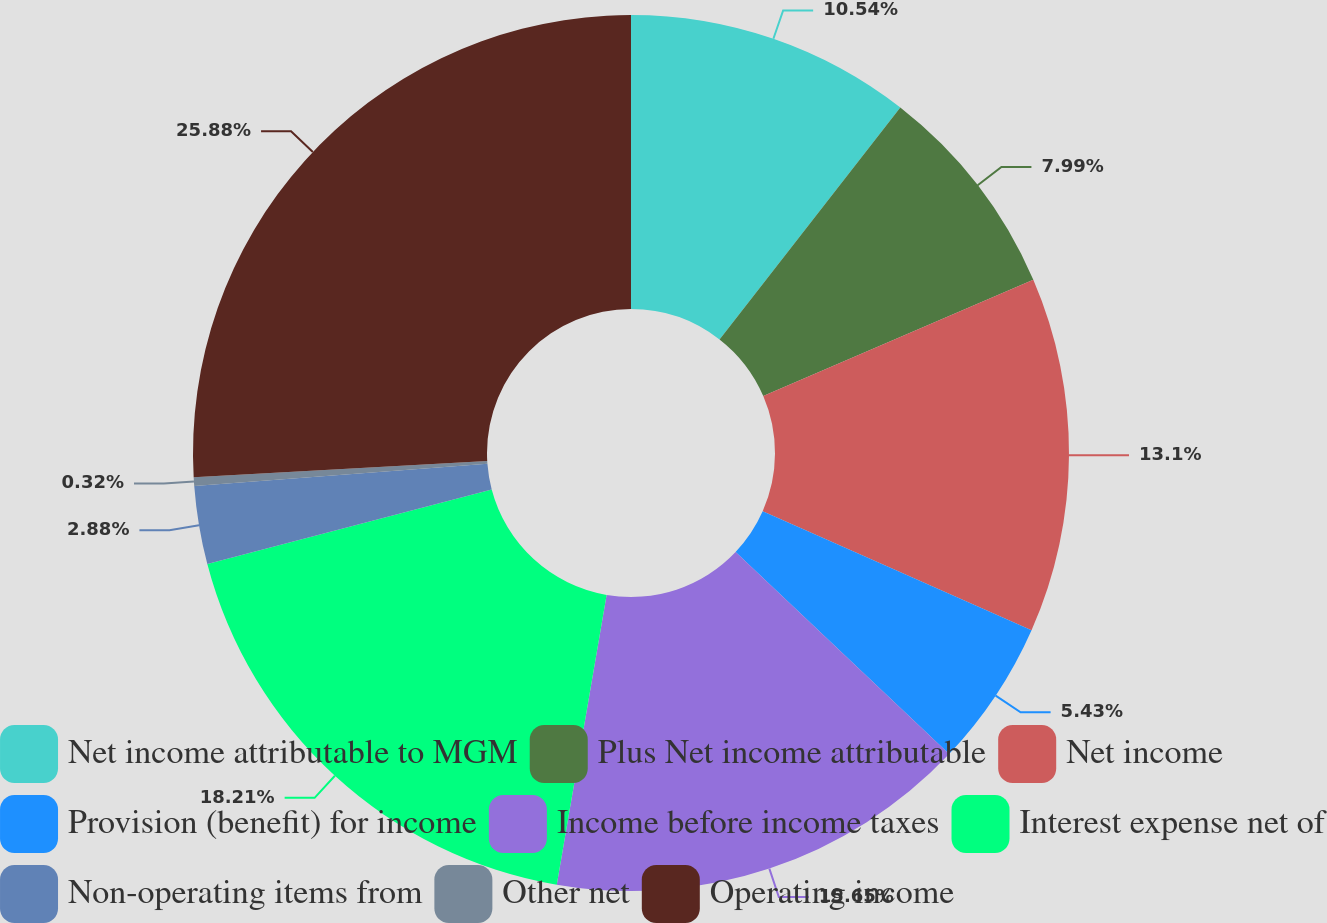<chart> <loc_0><loc_0><loc_500><loc_500><pie_chart><fcel>Net income attributable to MGM<fcel>Plus Net income attributable<fcel>Net income<fcel>Provision (benefit) for income<fcel>Income before income taxes<fcel>Interest expense net of<fcel>Non-operating items from<fcel>Other net<fcel>Operating income<nl><fcel>10.54%<fcel>7.99%<fcel>13.1%<fcel>5.43%<fcel>15.65%<fcel>18.21%<fcel>2.88%<fcel>0.32%<fcel>25.88%<nl></chart> 